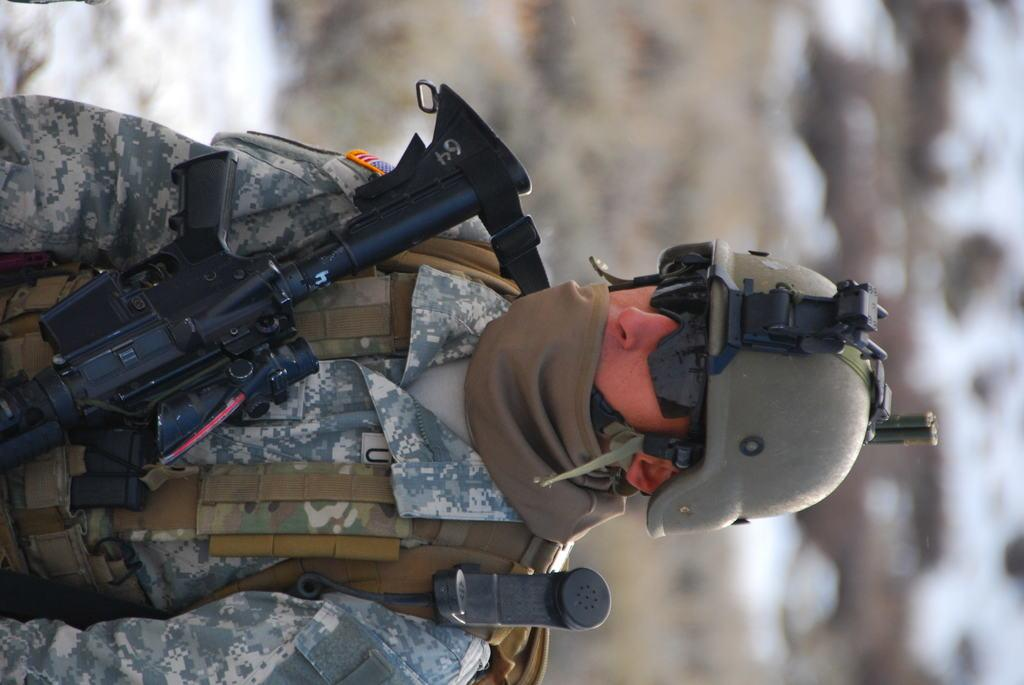Who is present in the image? There is a man in the image. What is the man holding in the image? The man is holding a gun. What type of clothing is the man wearing in the image? The man is wearing a military uniform. What type of list can be seen in the man's hand in the image? There is no list present in the man's hand in the image; he is holding a gun. 